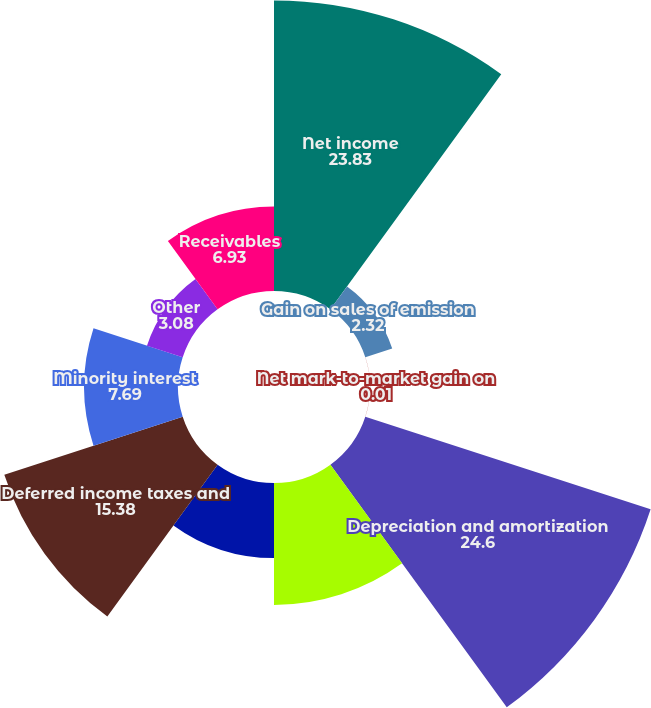Convert chart to OTSL. <chart><loc_0><loc_0><loc_500><loc_500><pie_chart><fcel>Net income<fcel>Gain on sales of emission<fcel>Net mark-to-market gain on<fcel>Depreciation and amortization<fcel>Amortization of nuclear fuel<fcel>Amortization of debt issuance<fcel>Deferred income taxes and<fcel>Minority interest<fcel>Other<fcel>Receivables<nl><fcel>23.83%<fcel>2.32%<fcel>0.01%<fcel>24.6%<fcel>10.0%<fcel>6.16%<fcel>15.38%<fcel>7.69%<fcel>3.08%<fcel>6.93%<nl></chart> 